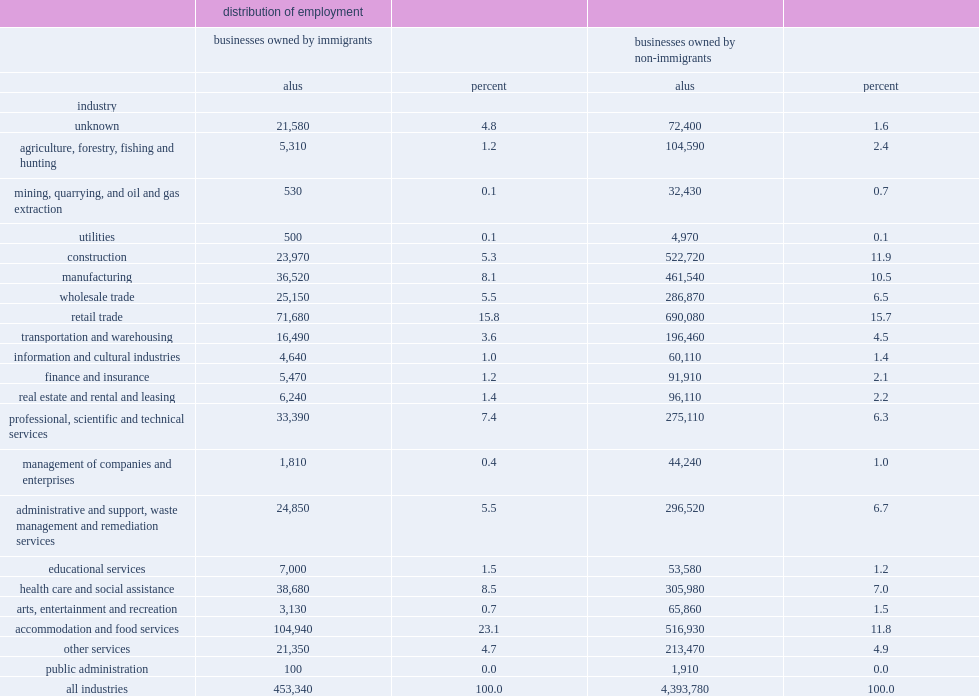What the total percent of accommodation and food services, retail trade, manufacturing, and health care and social assistance? 55.5. 